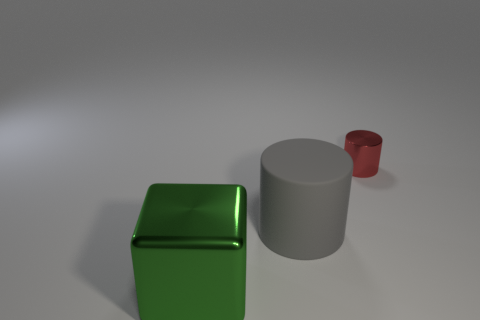Add 1 gray matte cylinders. How many objects exist? 4 Subtract all cubes. How many objects are left? 2 Subtract all large purple metal spheres. Subtract all big gray objects. How many objects are left? 2 Add 1 gray objects. How many gray objects are left? 2 Add 1 big green matte cubes. How many big green matte cubes exist? 1 Subtract 0 brown blocks. How many objects are left? 3 